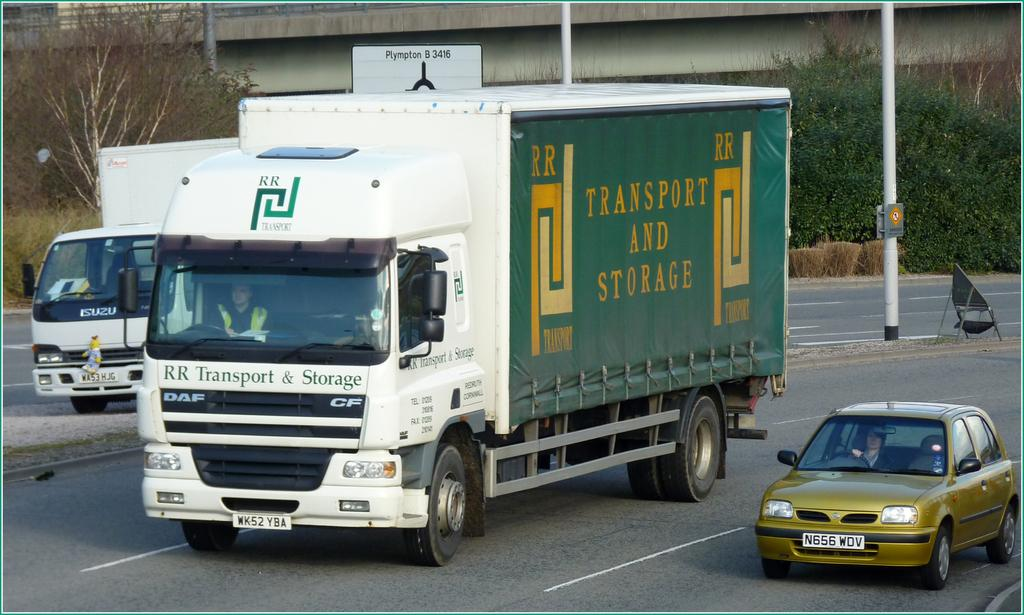How many trucks are visible in the image? There are 2 trucks in the image. Who is driving one of the trucks? A person is driving one of the trucks. What other vehicle is present in the image? There is a car beside one of the trucks. Who is driving the car? A person is driving the car. What can be seen in the background of the image? There are trees, poles, and a bridge in the background of the image. What attempt is being made by the fowl in the image? There is no fowl present in the image, so no attempt can be observed. 